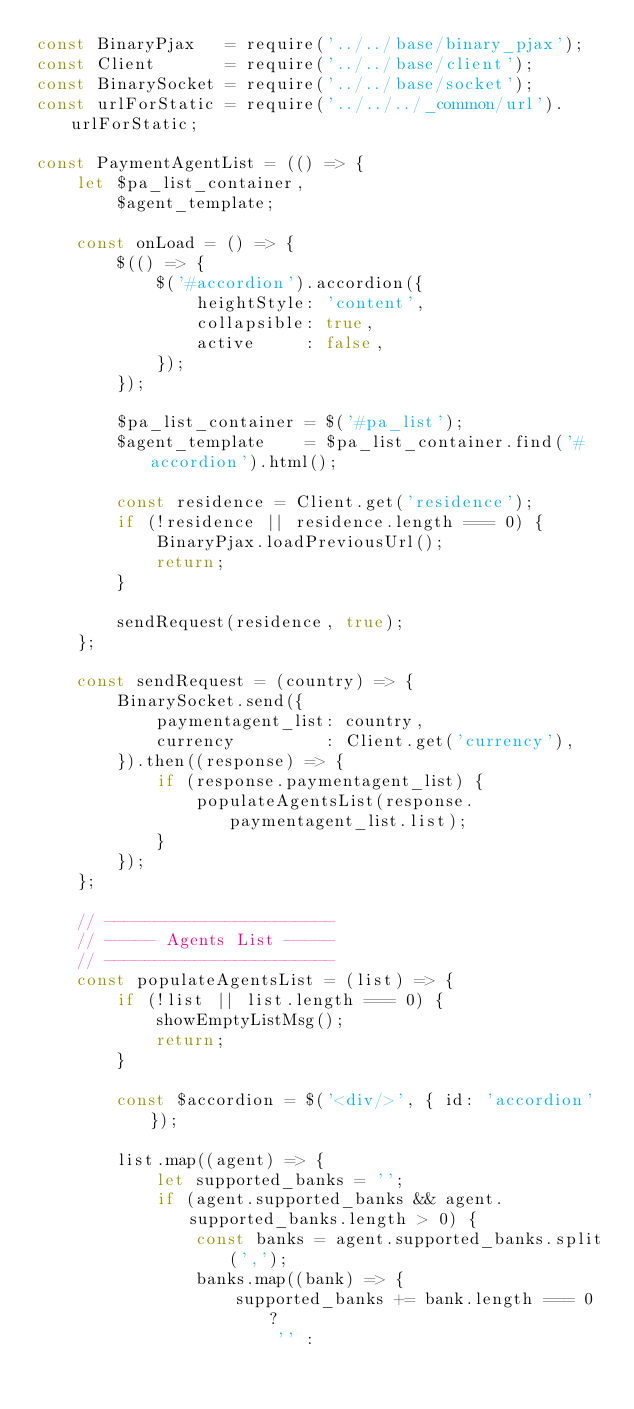<code> <loc_0><loc_0><loc_500><loc_500><_JavaScript_>const BinaryPjax   = require('../../base/binary_pjax');
const Client       = require('../../base/client');
const BinarySocket = require('../../base/socket');
const urlForStatic = require('../../../_common/url').urlForStatic;

const PaymentAgentList = (() => {
    let $pa_list_container,
        $agent_template;

    const onLoad = () => {
        $(() => {
            $('#accordion').accordion({
                heightStyle: 'content',
                collapsible: true,
                active     : false,
            });
        });

        $pa_list_container = $('#pa_list');
        $agent_template    = $pa_list_container.find('#accordion').html();

        const residence = Client.get('residence');
        if (!residence || residence.length === 0) {
            BinaryPjax.loadPreviousUrl();
            return;
        }

        sendRequest(residence, true);
    };

    const sendRequest = (country) => {
        BinarySocket.send({
            paymentagent_list: country,
            currency         : Client.get('currency'),
        }).then((response) => {
            if (response.paymentagent_list) {
                populateAgentsList(response.paymentagent_list.list);
            }
        });
    };

    // -----------------------
    // ----- Agents List -----
    // -----------------------
    const populateAgentsList = (list) => {
        if (!list || list.length === 0) {
            showEmptyListMsg();
            return;
        }

        const $accordion = $('<div/>', { id: 'accordion' });

        list.map((agent) => {
            let supported_banks = '';
            if (agent.supported_banks && agent.supported_banks.length > 0) {
                const banks = agent.supported_banks.split(',');
                banks.map((bank) => {
                    supported_banks += bank.length === 0 ?
                        '' :</code> 